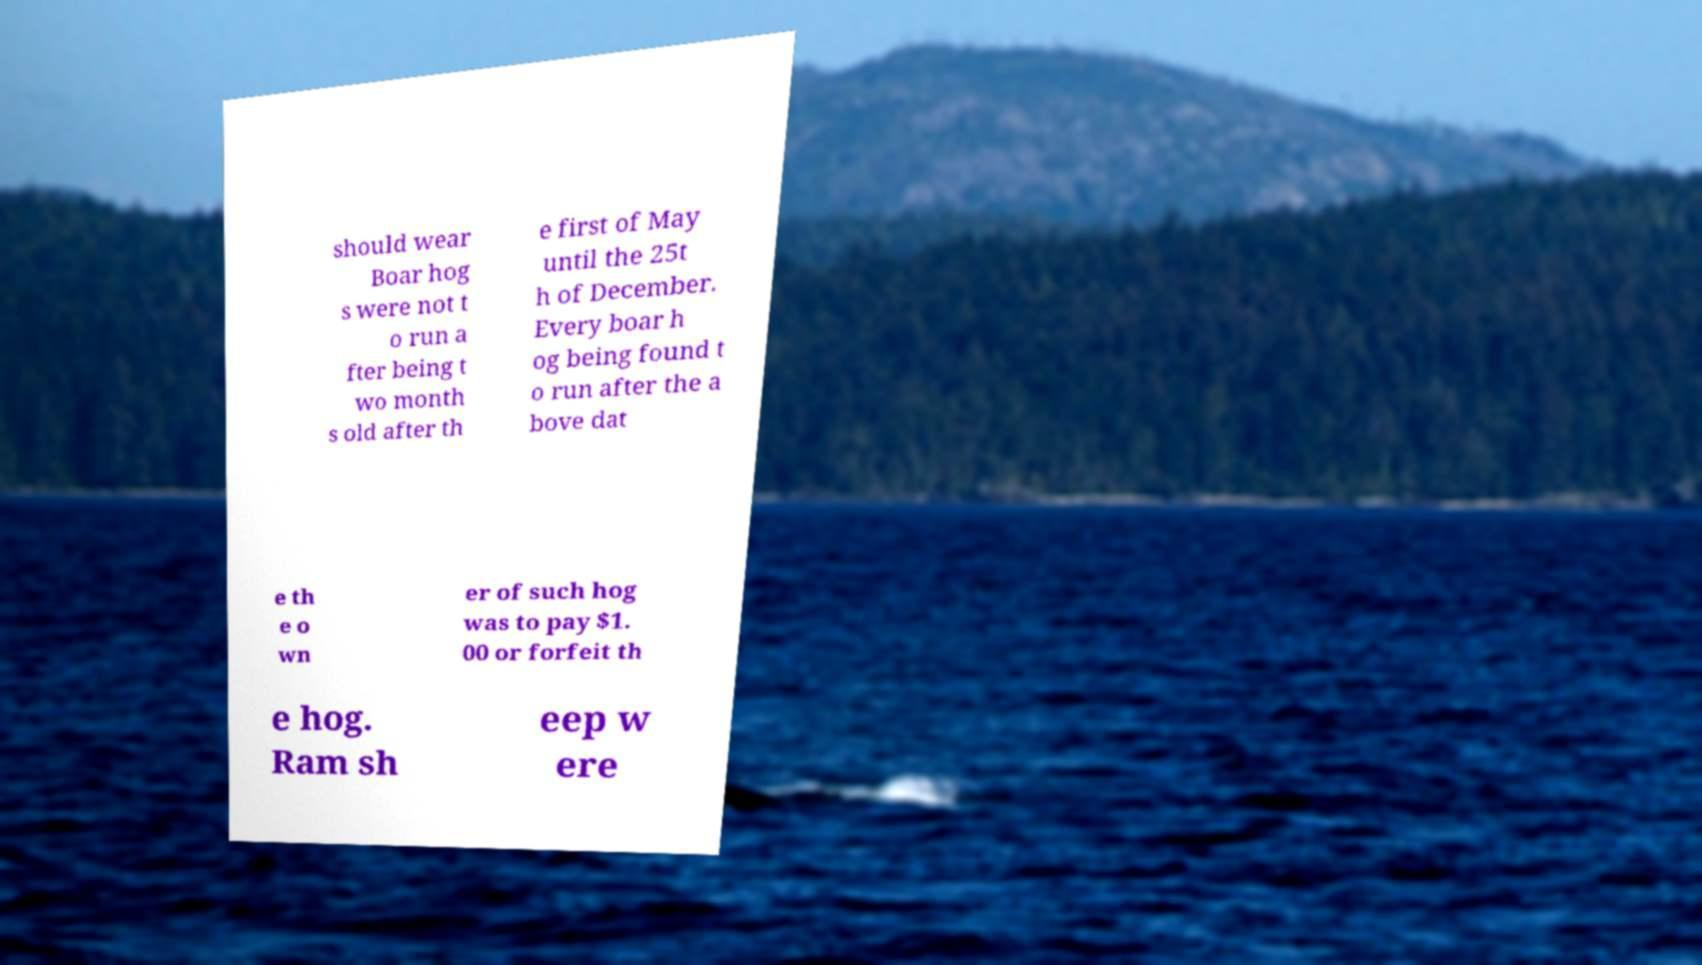Please read and relay the text visible in this image. What does it say? should wear Boar hog s were not t o run a fter being t wo month s old after th e first of May until the 25t h of December. Every boar h og being found t o run after the a bove dat e th e o wn er of such hog was to pay $1. 00 or forfeit th e hog. Ram sh eep w ere 